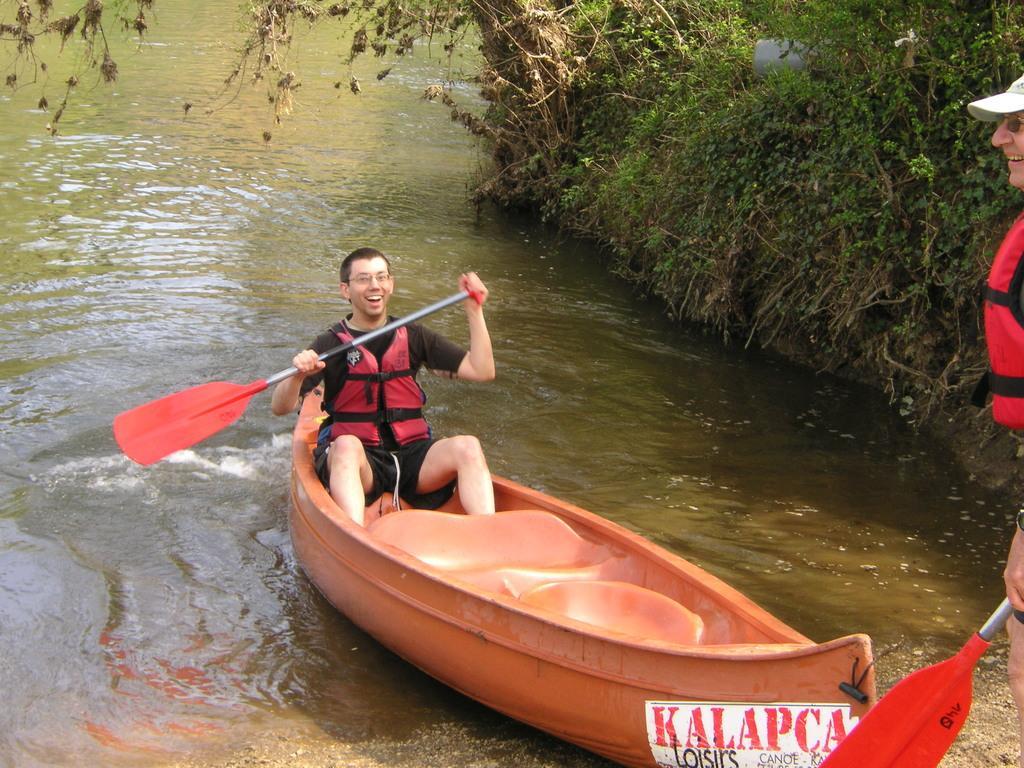Could you give a brief overview of what you see in this image? In this image in the center there is one person sitting on boat, and he is holding a stick. At the bottom there is a river, and on the right side of the image there is one person standing and he is smiling and he is wearing a cap and he is holding a stick. And on the right side of the image there are some plants, at the bottom there is some sand. 